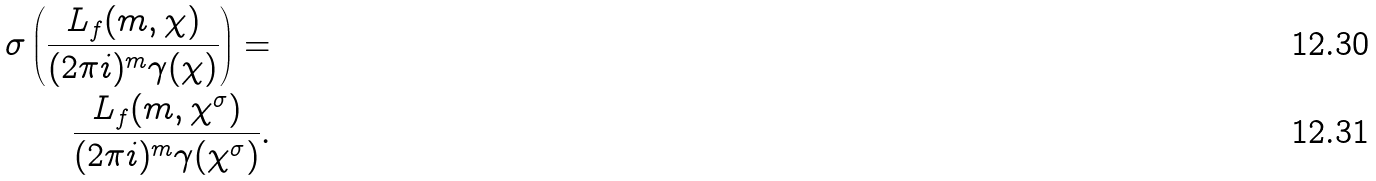<formula> <loc_0><loc_0><loc_500><loc_500>\sigma \left ( \frac { L _ { f } ( m , \chi ) } { ( 2 \pi i ) ^ { m } \gamma ( \chi ) } \right ) = \\ \frac { L _ { f } ( m , \chi ^ { \sigma } ) } { ( 2 \pi i ) ^ { m } \gamma ( \chi ^ { \sigma } ) } .</formula> 